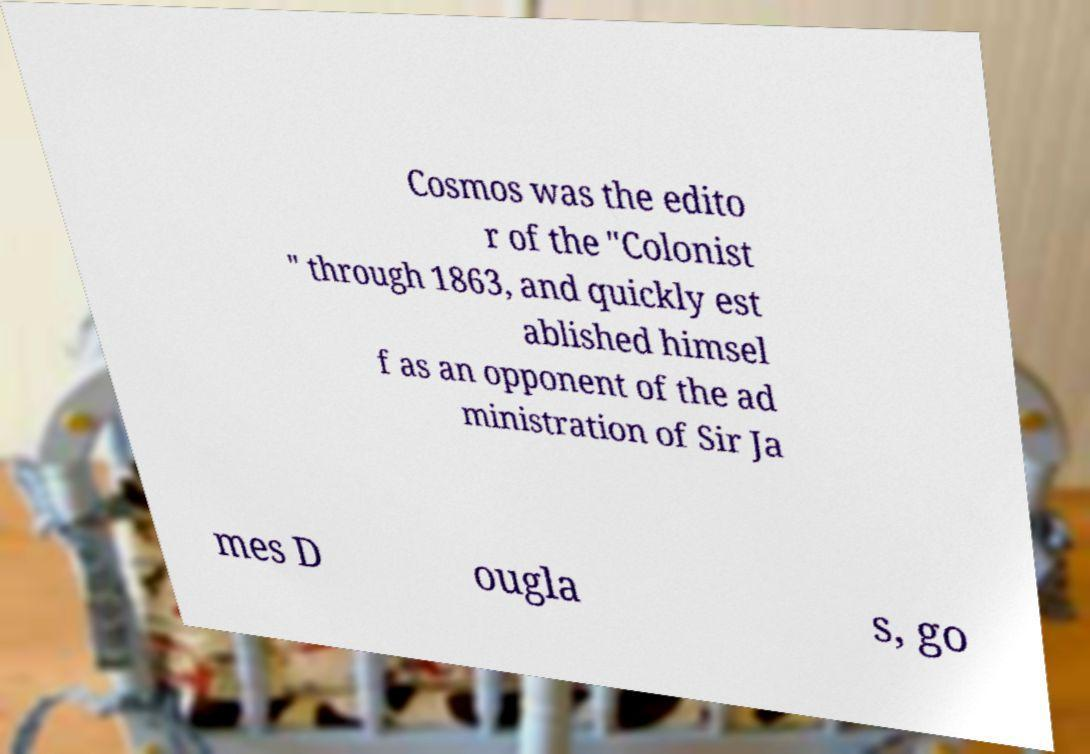Could you extract and type out the text from this image? Cosmos was the edito r of the "Colonist " through 1863, and quickly est ablished himsel f as an opponent of the ad ministration of Sir Ja mes D ougla s, go 